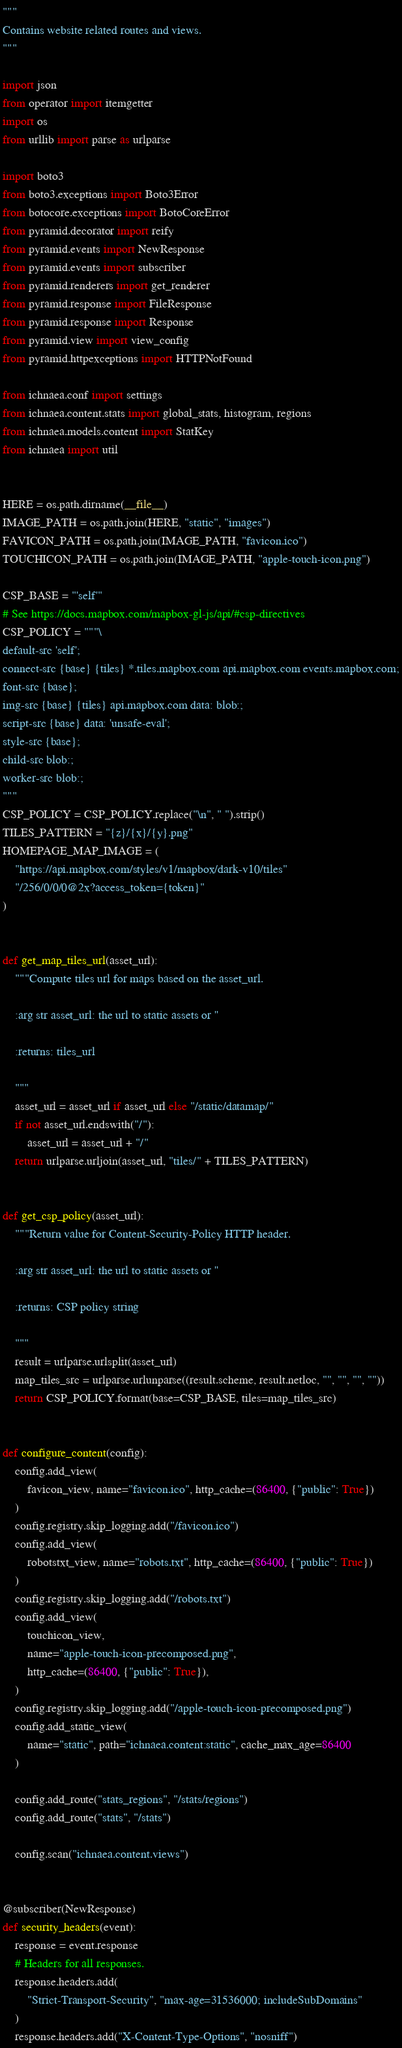<code> <loc_0><loc_0><loc_500><loc_500><_Python_>"""
Contains website related routes and views.
"""

import json
from operator import itemgetter
import os
from urllib import parse as urlparse

import boto3
from boto3.exceptions import Boto3Error
from botocore.exceptions import BotoCoreError
from pyramid.decorator import reify
from pyramid.events import NewResponse
from pyramid.events import subscriber
from pyramid.renderers import get_renderer
from pyramid.response import FileResponse
from pyramid.response import Response
from pyramid.view import view_config
from pyramid.httpexceptions import HTTPNotFound

from ichnaea.conf import settings
from ichnaea.content.stats import global_stats, histogram, regions
from ichnaea.models.content import StatKey
from ichnaea import util


HERE = os.path.dirname(__file__)
IMAGE_PATH = os.path.join(HERE, "static", "images")
FAVICON_PATH = os.path.join(IMAGE_PATH, "favicon.ico")
TOUCHICON_PATH = os.path.join(IMAGE_PATH, "apple-touch-icon.png")

CSP_BASE = "'self'"
# See https://docs.mapbox.com/mapbox-gl-js/api/#csp-directives
CSP_POLICY = """\
default-src 'self';
connect-src {base} {tiles} *.tiles.mapbox.com api.mapbox.com events.mapbox.com;
font-src {base};
img-src {base} {tiles} api.mapbox.com data: blob:;
script-src {base} data: 'unsafe-eval';
style-src {base};
child-src blob:;
worker-src blob:;
"""
CSP_POLICY = CSP_POLICY.replace("\n", " ").strip()
TILES_PATTERN = "{z}/{x}/{y}.png"
HOMEPAGE_MAP_IMAGE = (
    "https://api.mapbox.com/styles/v1/mapbox/dark-v10/tiles"
    "/256/0/0/0@2x?access_token={token}"
)


def get_map_tiles_url(asset_url):
    """Compute tiles url for maps based on the asset_url.

    :arg str asset_url: the url to static assets or ''

    :returns: tiles_url

    """
    asset_url = asset_url if asset_url else "/static/datamap/"
    if not asset_url.endswith("/"):
        asset_url = asset_url + "/"
    return urlparse.urljoin(asset_url, "tiles/" + TILES_PATTERN)


def get_csp_policy(asset_url):
    """Return value for Content-Security-Policy HTTP header.

    :arg str asset_url: the url to static assets or ''

    :returns: CSP policy string

    """
    result = urlparse.urlsplit(asset_url)
    map_tiles_src = urlparse.urlunparse((result.scheme, result.netloc, "", "", "", ""))
    return CSP_POLICY.format(base=CSP_BASE, tiles=map_tiles_src)


def configure_content(config):
    config.add_view(
        favicon_view, name="favicon.ico", http_cache=(86400, {"public": True})
    )
    config.registry.skip_logging.add("/favicon.ico")
    config.add_view(
        robotstxt_view, name="robots.txt", http_cache=(86400, {"public": True})
    )
    config.registry.skip_logging.add("/robots.txt")
    config.add_view(
        touchicon_view,
        name="apple-touch-icon-precomposed.png",
        http_cache=(86400, {"public": True}),
    )
    config.registry.skip_logging.add("/apple-touch-icon-precomposed.png")
    config.add_static_view(
        name="static", path="ichnaea.content:static", cache_max_age=86400
    )

    config.add_route("stats_regions", "/stats/regions")
    config.add_route("stats", "/stats")

    config.scan("ichnaea.content.views")


@subscriber(NewResponse)
def security_headers(event):
    response = event.response
    # Headers for all responses.
    response.headers.add(
        "Strict-Transport-Security", "max-age=31536000; includeSubDomains"
    )
    response.headers.add("X-Content-Type-Options", "nosniff")</code> 